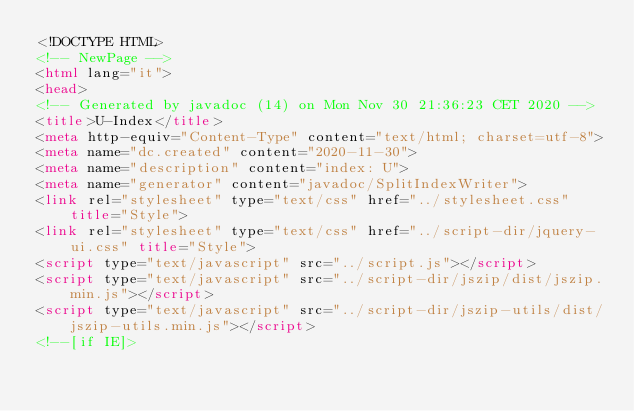Convert code to text. <code><loc_0><loc_0><loc_500><loc_500><_HTML_><!DOCTYPE HTML>
<!-- NewPage -->
<html lang="it">
<head>
<!-- Generated by javadoc (14) on Mon Nov 30 21:36:23 CET 2020 -->
<title>U-Index</title>
<meta http-equiv="Content-Type" content="text/html; charset=utf-8">
<meta name="dc.created" content="2020-11-30">
<meta name="description" content="index: U">
<meta name="generator" content="javadoc/SplitIndexWriter">
<link rel="stylesheet" type="text/css" href="../stylesheet.css" title="Style">
<link rel="stylesheet" type="text/css" href="../script-dir/jquery-ui.css" title="Style">
<script type="text/javascript" src="../script.js"></script>
<script type="text/javascript" src="../script-dir/jszip/dist/jszip.min.js"></script>
<script type="text/javascript" src="../script-dir/jszip-utils/dist/jszip-utils.min.js"></script>
<!--[if IE]></code> 